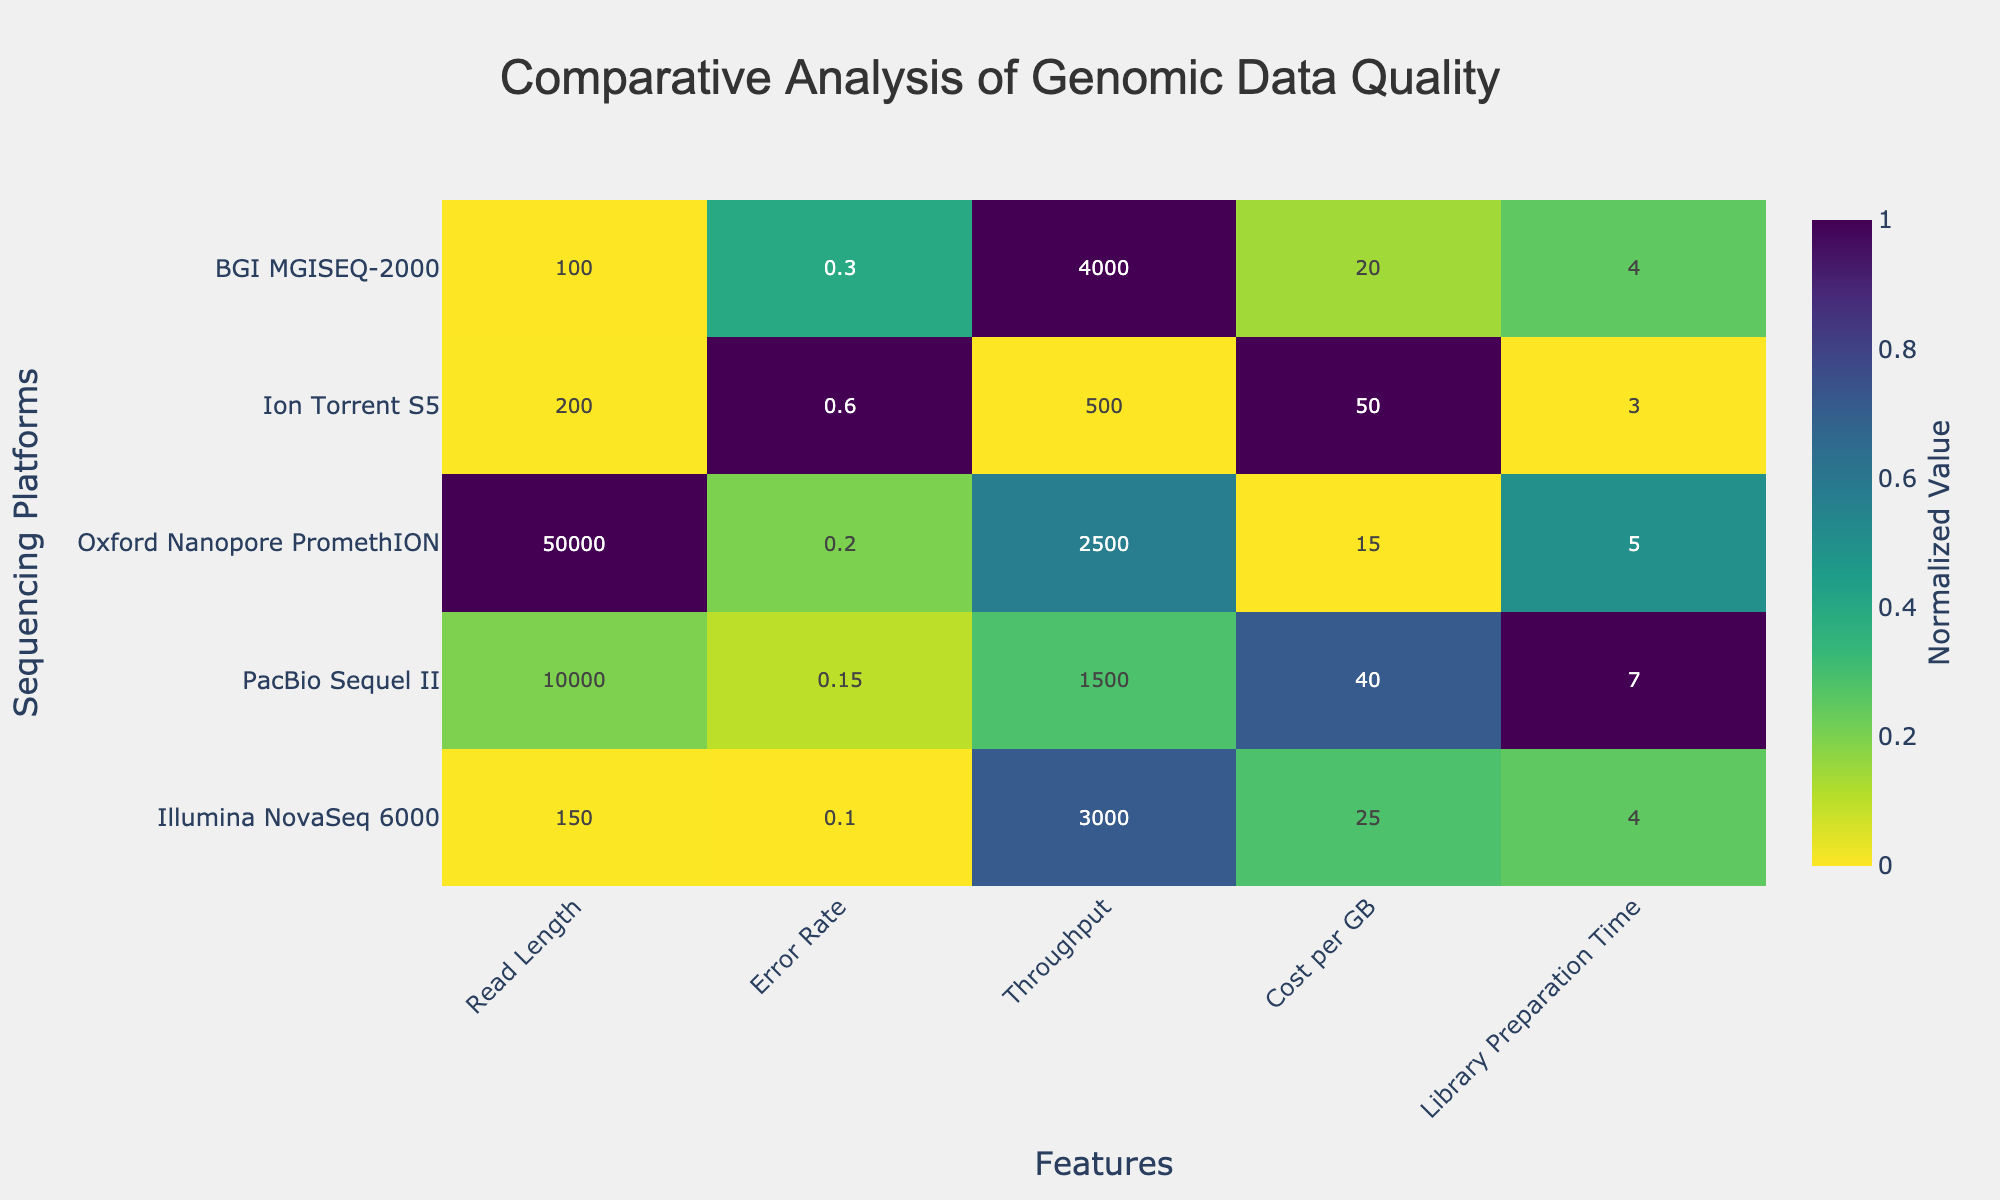What is the title of the heatmap? The title is located at the top center of the heatmap and typically represents the main topic or focus of the visual.
Answer: Comparative Analysis of Genomic Data Quality Which sequencing platform has the highest normalized throughput? Look at the row labeled "Throughput" and identify the cell with the highest value. Refer to the corresponding platform label on the y-axis.
Answer: BGI MGISEQ-2000 What does the color scale represent in this heatmap? The color scale indicates the normalized values of the features across the sequencing platforms, with colors changing from light to dark to show variations.
Answer: Normalized value How does Oxford Nanopore PromethION compare to Illumina NovaSeq 6000 in terms of error rate? Compare the normalized error rate values for the two platforms (second column).
Answer: Oxford Nanopore PromethION has a higher error rate than Illumina NovaSeq 6000 Which platform has the shortest read length and where does it rank in terms of error rate? Identify the platform with the smallest value in the "Read Length" column and check its position in the "Error Rate" column.
Answer: BGI MGISEQ-2000 has the shortest read length and has a lower error rate than Ion Torrent S5 but a higher error rate than Illumina NovaSeq 6000 and PacBio Sequel II What visual feature suggests the library preparation time for Ion Torrent S5? Check the row labeled "Ion Torrent S5" and locate the cell under "Library Preparation Time" to understand its normalized value based on the color intensity.
Answer: The dark color in the "Library Preparation Time" indicates a shorter preparation time Compare the cost per GB of PacBio Sequel II and Oxford Nanopore PromethION. which one is more cost-effective? Look at the normalized values in the "Cost per GB" column for these two platforms and determine which has a lower value.
Answer: Oxford Nanopore PromethION is more cost-effective Which sequencing platform is the best overall based on normalized values across all features? Evaluate each platform across all normalized features and identify the one with the consistently lowest normalized values (indicating better performance).
Answer: Illumina NovaSeq 6000 What is the normalized value for the read length of PacBio Sequel II? Check the intersection of PacBio Sequel II and the "Read Length" column for the normalized value.
Answer: Approximately 0.2 What feature has the highest variability among the sequencing platforms? Compare the range of normalized values across all features to determine which feature varies the most.
Answer: Error Rate 